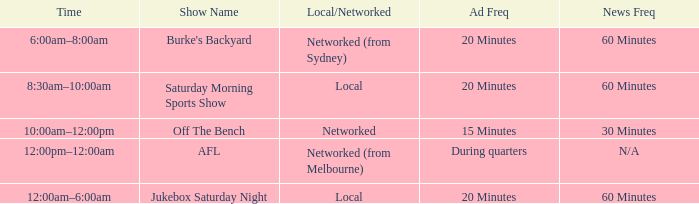What is the local/network featuring a 15-minute ad recurrence? Networked. 